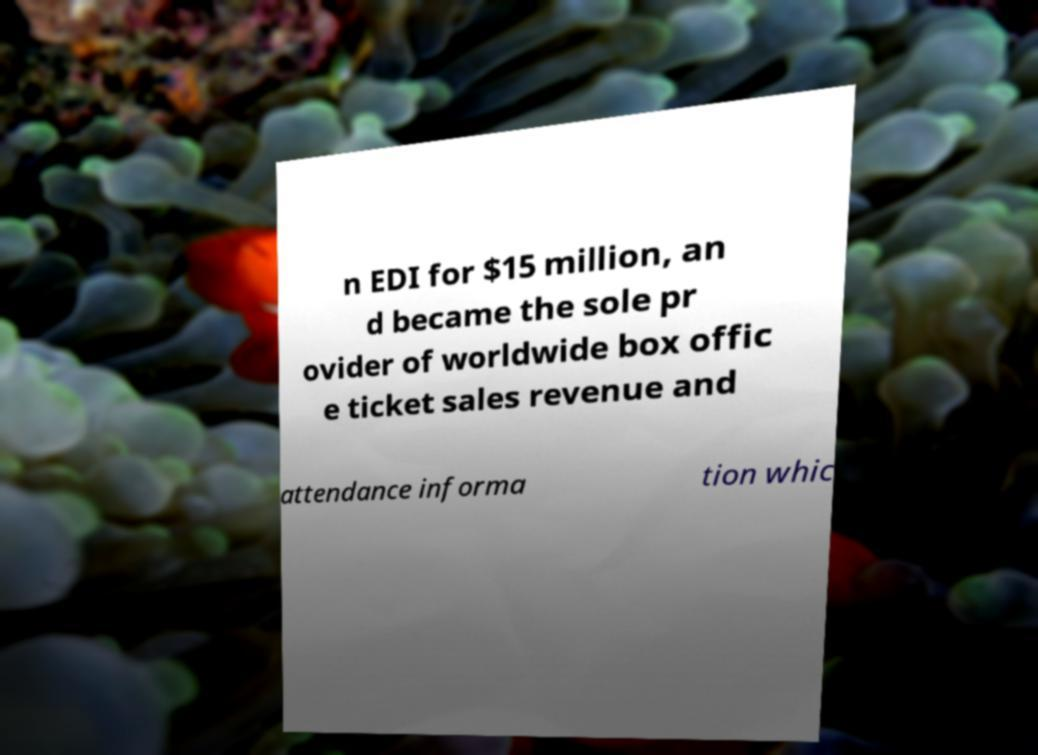Could you assist in decoding the text presented in this image and type it out clearly? n EDI for $15 million, an d became the sole pr ovider of worldwide box offic e ticket sales revenue and attendance informa tion whic 